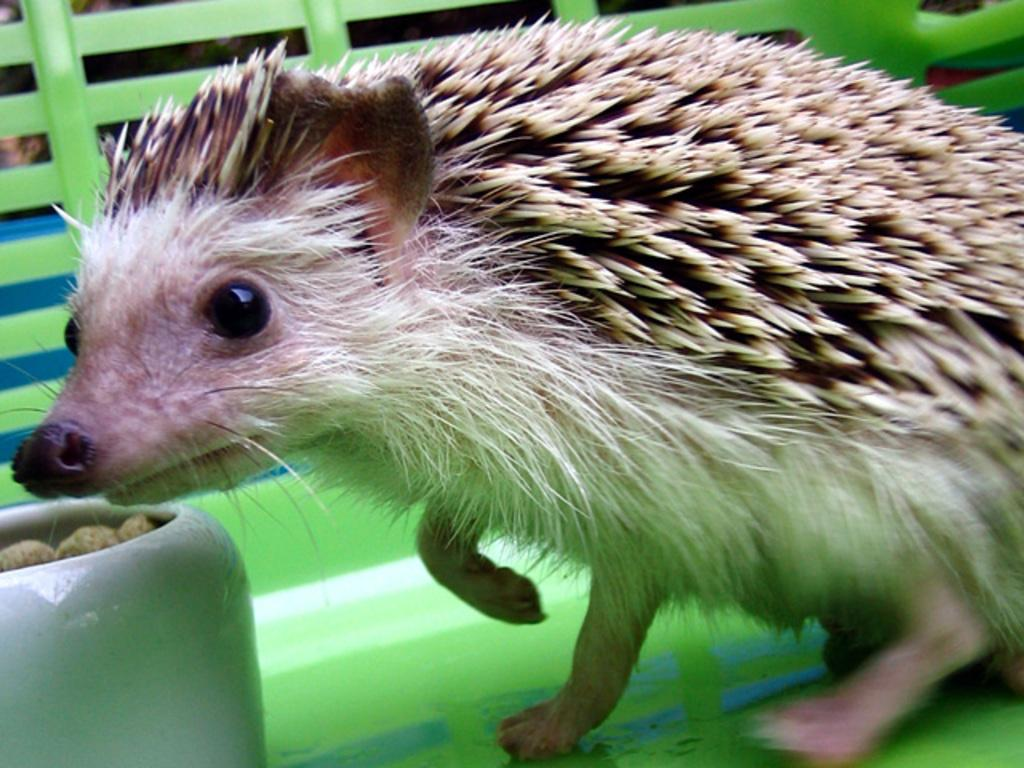What is the main subject in the center of the image? There is an animal in the center of the image. What can be seen on the left side of the image? There is a bowl on the left side of the image. What is inside the bowl? There are items in the bowl. What can be seen in the background of the image? There is a fence in the background of the image. How many steps does the giraffe take to reach the top of the fence in the image? There is no giraffe present in the image, so it is not possible to answer that question. 